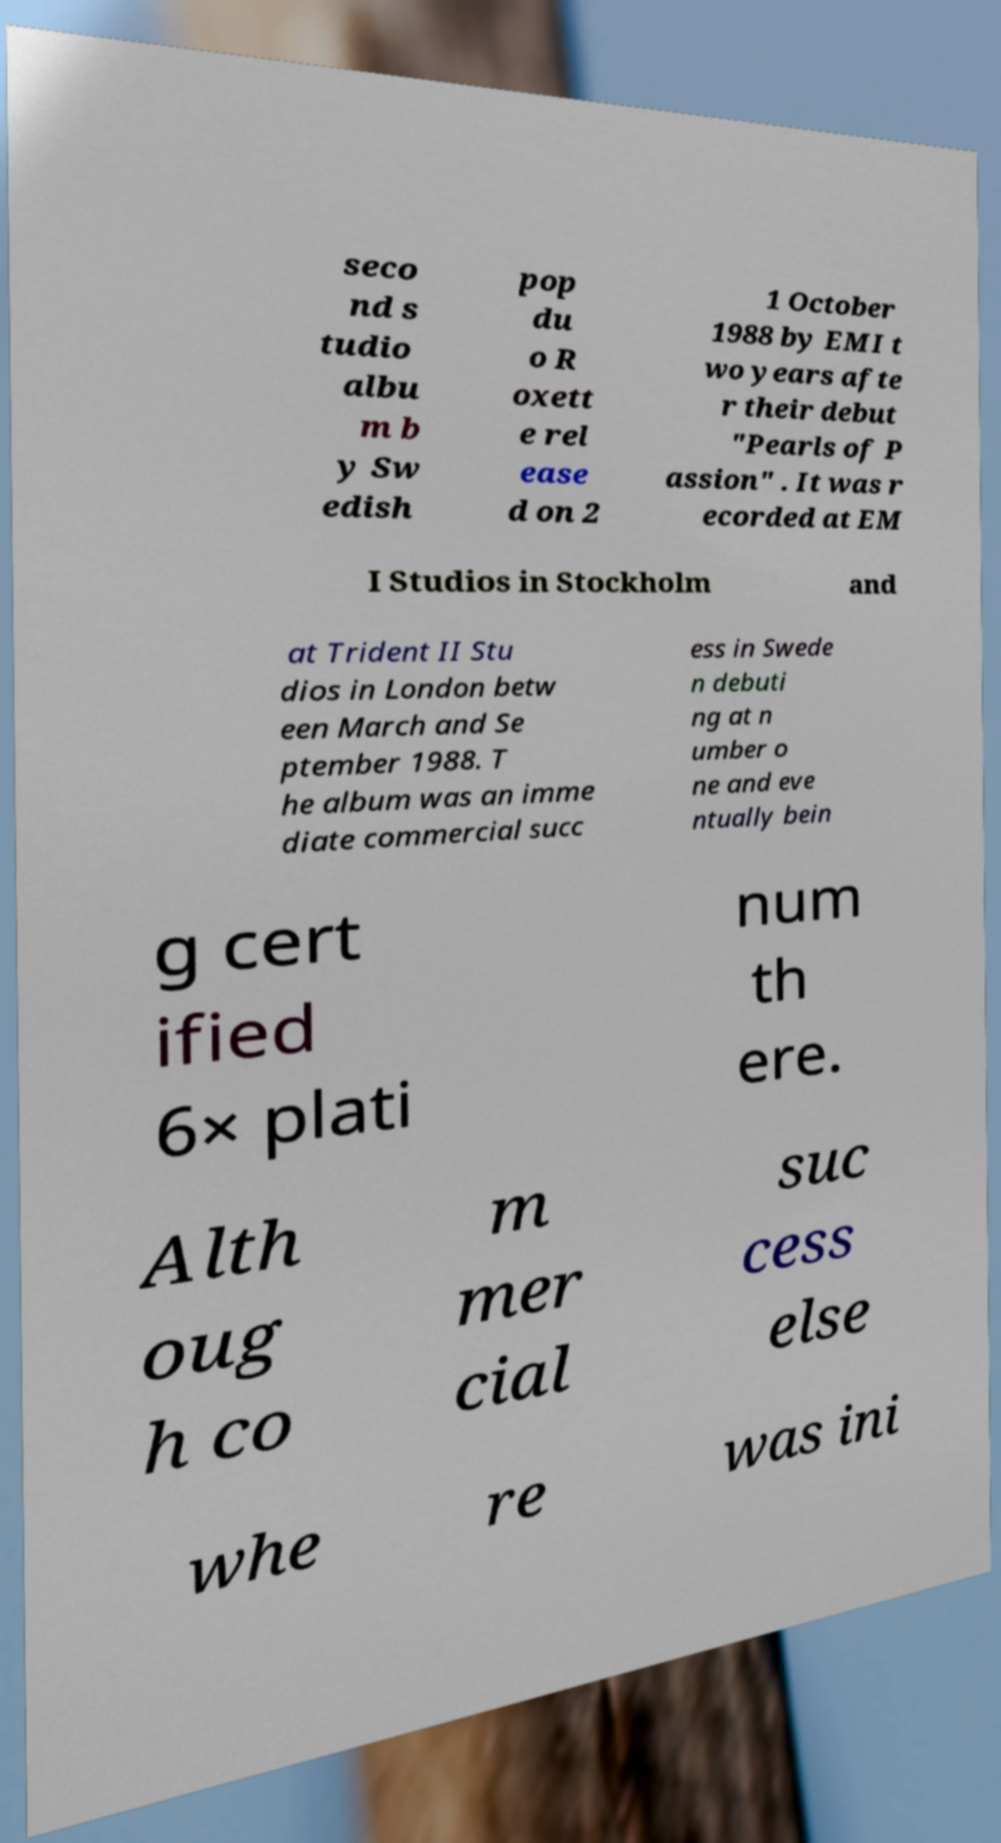Please read and relay the text visible in this image. What does it say? seco nd s tudio albu m b y Sw edish pop du o R oxett e rel ease d on 2 1 October 1988 by EMI t wo years afte r their debut "Pearls of P assion" . It was r ecorded at EM I Studios in Stockholm and at Trident II Stu dios in London betw een March and Se ptember 1988. T he album was an imme diate commercial succ ess in Swede n debuti ng at n umber o ne and eve ntually bein g cert ified 6× plati num th ere. Alth oug h co m mer cial suc cess else whe re was ini 